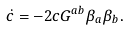Convert formula to latex. <formula><loc_0><loc_0><loc_500><loc_500>\dot { c } = - 2 c G ^ { a b } \beta _ { a } \beta _ { b } .</formula> 